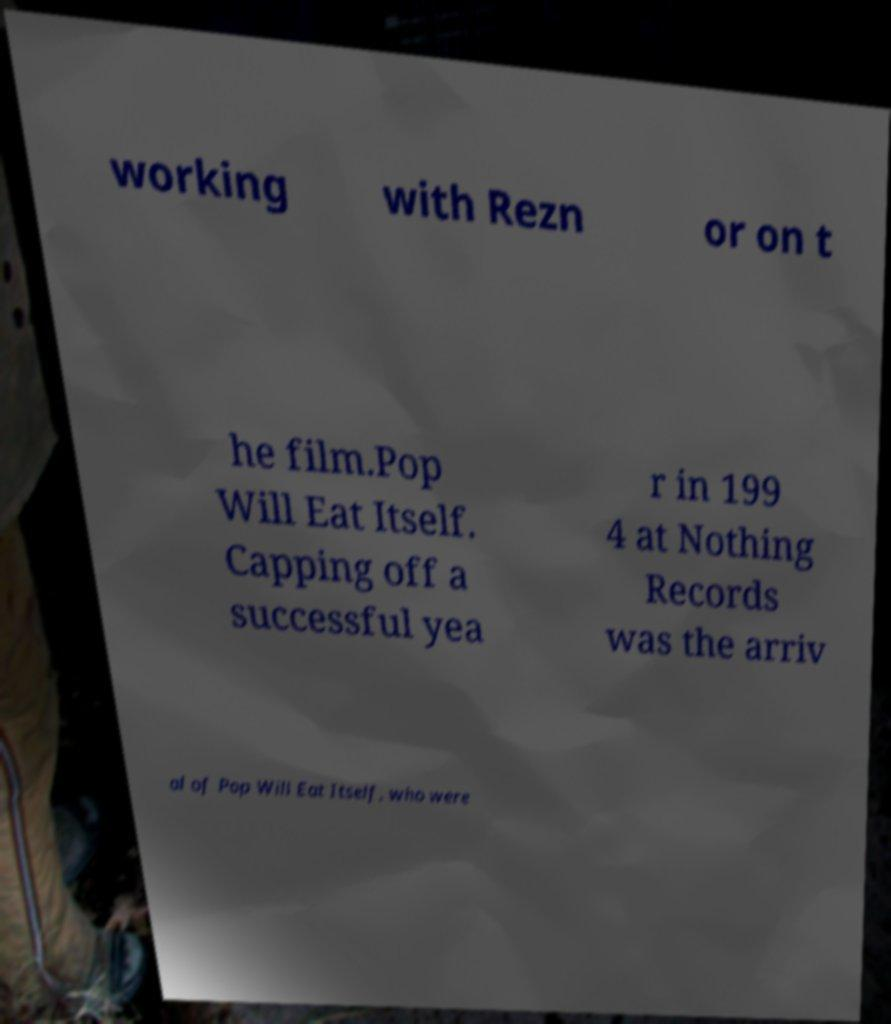Could you extract and type out the text from this image? working with Rezn or on t he film.Pop Will Eat Itself. Capping off a successful yea r in 199 4 at Nothing Records was the arriv al of Pop Will Eat Itself, who were 